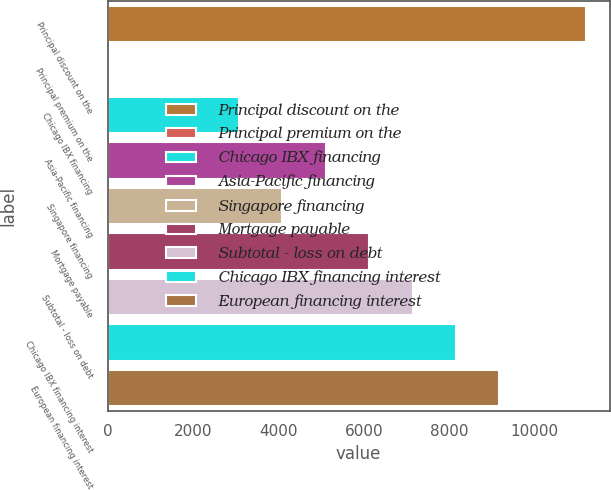Convert chart. <chart><loc_0><loc_0><loc_500><loc_500><bar_chart><fcel>Principal discount on the<fcel>Principal premium on the<fcel>Chicago IBX financing<fcel>Asia-Pacific financing<fcel>Singapore financing<fcel>Mortgage payable<fcel>Subtotal - loss on debt<fcel>Chicago IBX financing interest<fcel>European financing interest<nl><fcel>11202.1<fcel>36<fcel>3081.3<fcel>5111.5<fcel>4096.4<fcel>6126.6<fcel>7141.7<fcel>8156.8<fcel>9171.9<nl></chart> 